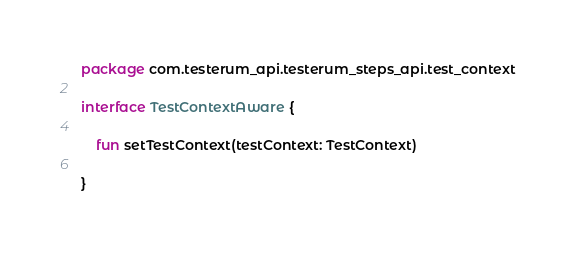Convert code to text. <code><loc_0><loc_0><loc_500><loc_500><_Kotlin_>package com.testerum_api.testerum_steps_api.test_context

interface TestContextAware {

    fun setTestContext(testContext: TestContext)

}
</code> 